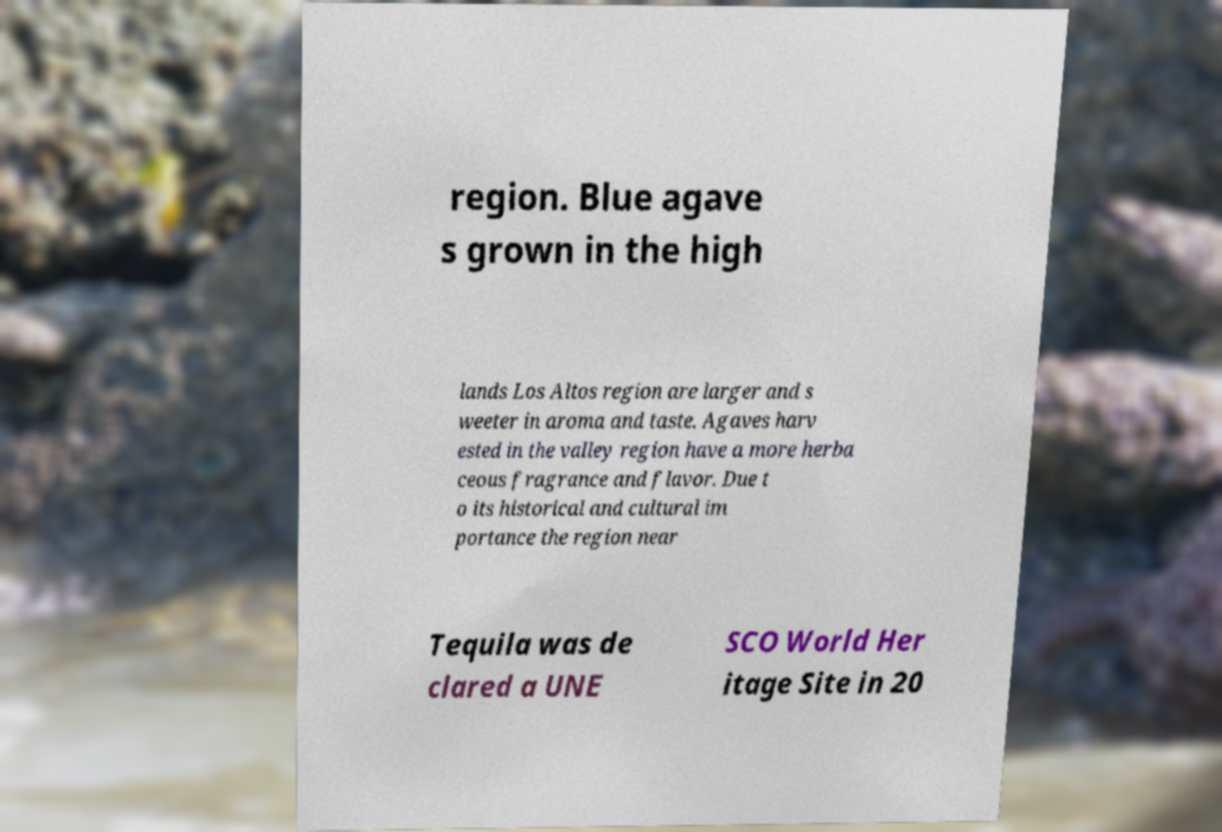I need the written content from this picture converted into text. Can you do that? region. Blue agave s grown in the high lands Los Altos region are larger and s weeter in aroma and taste. Agaves harv ested in the valley region have a more herba ceous fragrance and flavor. Due t o its historical and cultural im portance the region near Tequila was de clared a UNE SCO World Her itage Site in 20 